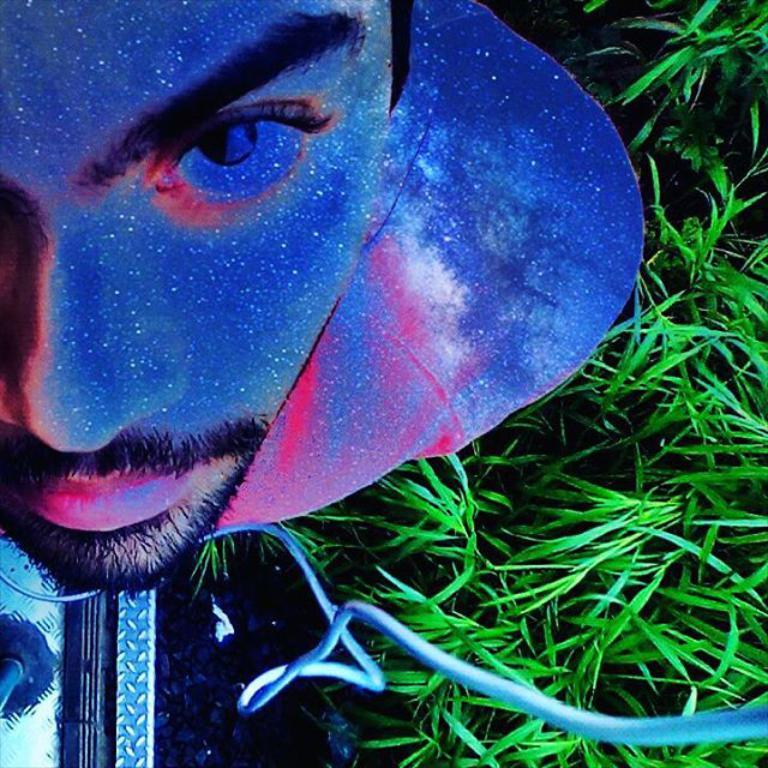What is the main subject of the image? The main subject of the image is an edited picture of a person. What else can be seen in the image besides the person? There is a pole, a wire, and grass visible in the image. What type of pen is being used to make an error in the image? There is no pen or error present in the image; it is an edited picture of a person with a pole, wire, and grass visible. 